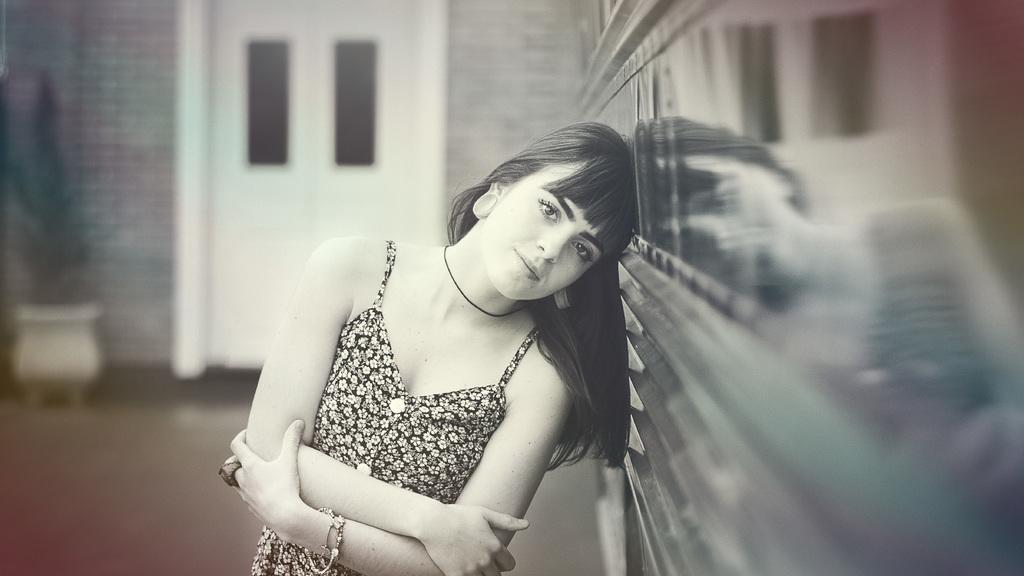Can you describe this image briefly? In this picture I can see there is a woman standing and she is wearing a black floral dress and there is a wall on right and in the backdrop there is a door and a plant. 